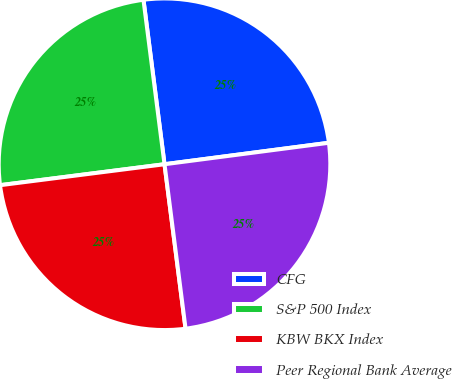Convert chart. <chart><loc_0><loc_0><loc_500><loc_500><pie_chart><fcel>CFG<fcel>S&P 500 Index<fcel>KBW BKX Index<fcel>Peer Regional Bank Average<nl><fcel>24.96%<fcel>24.99%<fcel>25.01%<fcel>25.04%<nl></chart> 